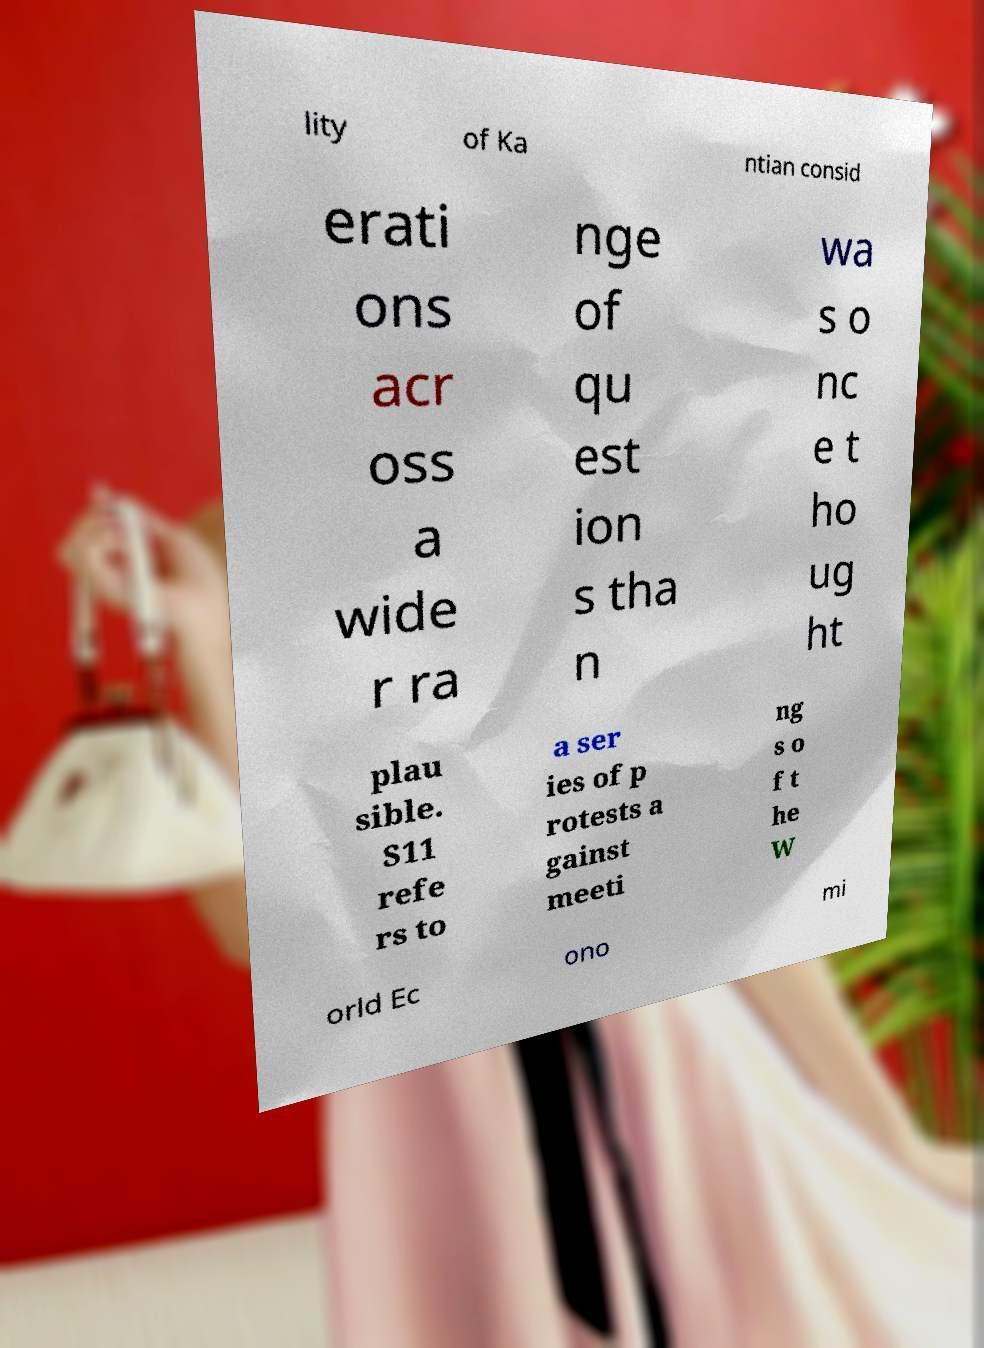Could you assist in decoding the text presented in this image and type it out clearly? lity of Ka ntian consid erati ons acr oss a wide r ra nge of qu est ion s tha n wa s o nc e t ho ug ht plau sible. S11 refe rs to a ser ies of p rotests a gainst meeti ng s o f t he W orld Ec ono mi 